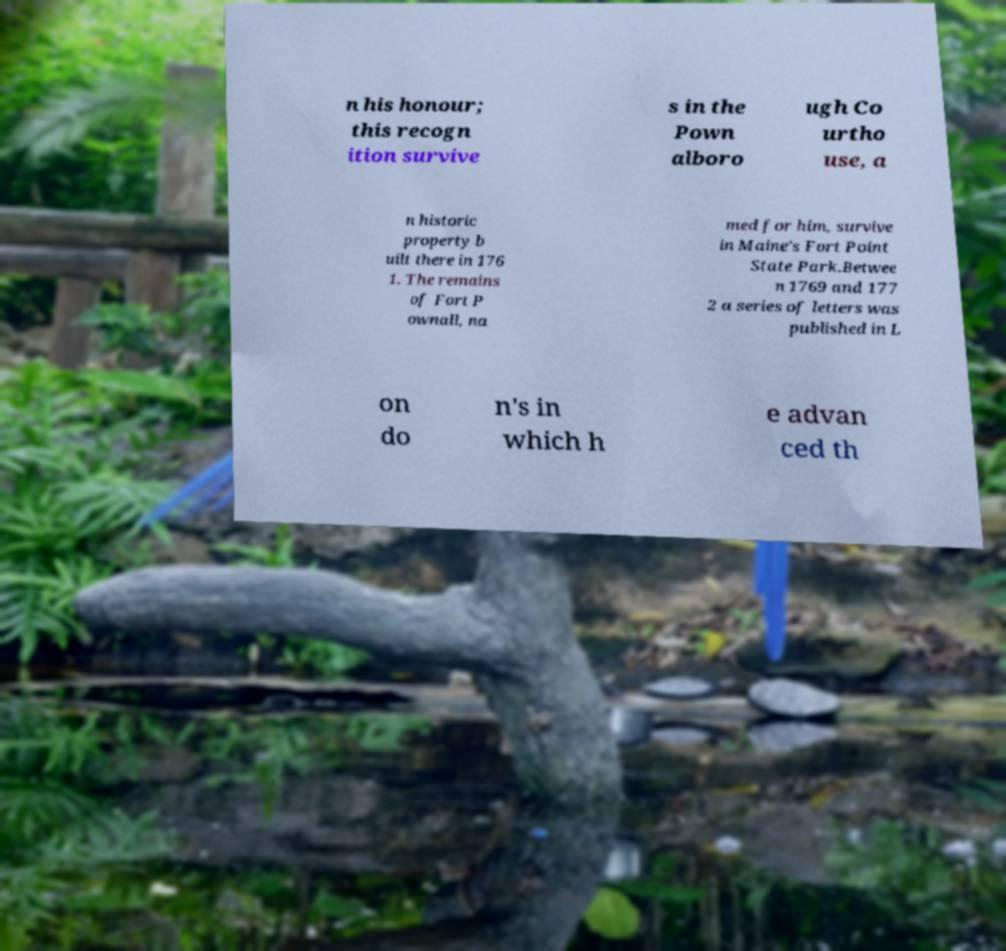Please read and relay the text visible in this image. What does it say? n his honour; this recogn ition survive s in the Pown alboro ugh Co urtho use, a n historic property b uilt there in 176 1. The remains of Fort P ownall, na med for him, survive in Maine's Fort Point State Park.Betwee n 1769 and 177 2 a series of letters was published in L on do n's in which h e advan ced th 